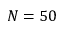Convert formula to latex. <formula><loc_0><loc_0><loc_500><loc_500>N = 5 0</formula> 